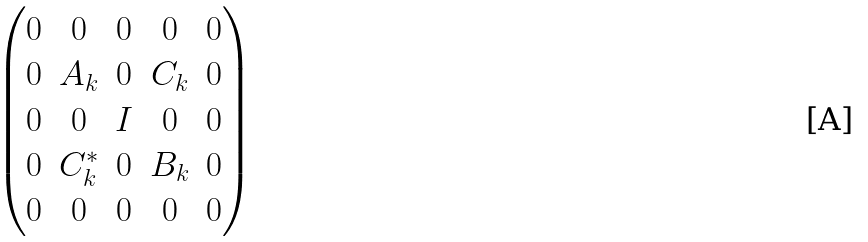<formula> <loc_0><loc_0><loc_500><loc_500>\begin{pmatrix} 0 & 0 & 0 & 0 & 0 \\ 0 & A _ { k } & 0 & C _ { k } & 0 \\ 0 & 0 & I & 0 & 0 \\ 0 & C _ { k } ^ { * } & 0 & B _ { k } & 0 \\ 0 & 0 & 0 & 0 & 0 \end{pmatrix}</formula> 